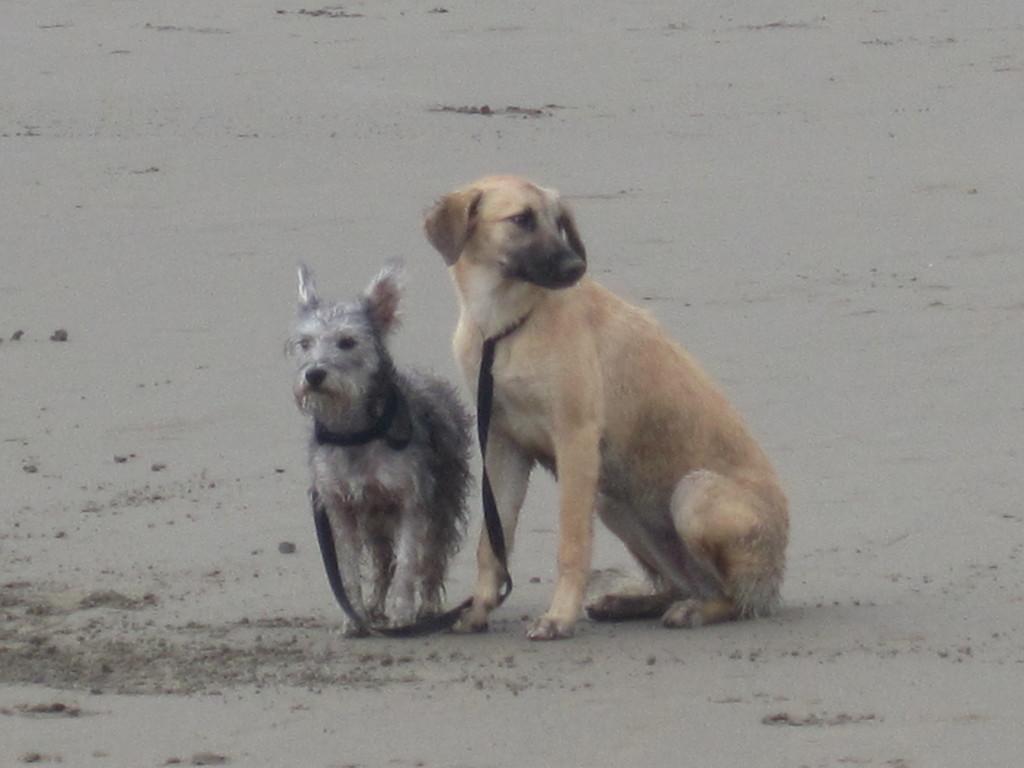How would you summarize this image in a sentence or two? In this image we can see the two dogs with the black belt. In the background we can see the sand. 